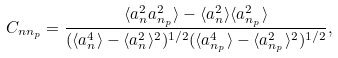Convert formula to latex. <formula><loc_0><loc_0><loc_500><loc_500>C _ { n n _ { p } } = \frac { \langle a _ { n } ^ { 2 } a _ { n _ { p } } ^ { 2 } \rangle - \langle a _ { n } ^ { 2 } \rangle \langle a _ { n _ { p } } ^ { 2 } \rangle } { ( \langle a _ { n } ^ { 4 } \rangle - \langle a _ { n } ^ { 2 } \rangle ^ { 2 } ) ^ { 1 / 2 } ( \langle a _ { n _ { p } } ^ { 4 } \rangle - \langle a _ { n _ { p } } ^ { 2 } \rangle ^ { 2 } ) ^ { 1 / 2 } } ,</formula> 